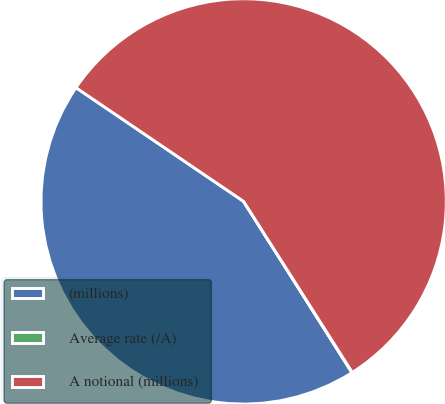Convert chart. <chart><loc_0><loc_0><loc_500><loc_500><pie_chart><fcel>(millions)<fcel>Average rate (/A)<fcel>A notional (millions)<nl><fcel>43.46%<fcel>0.03%<fcel>56.5%<nl></chart> 